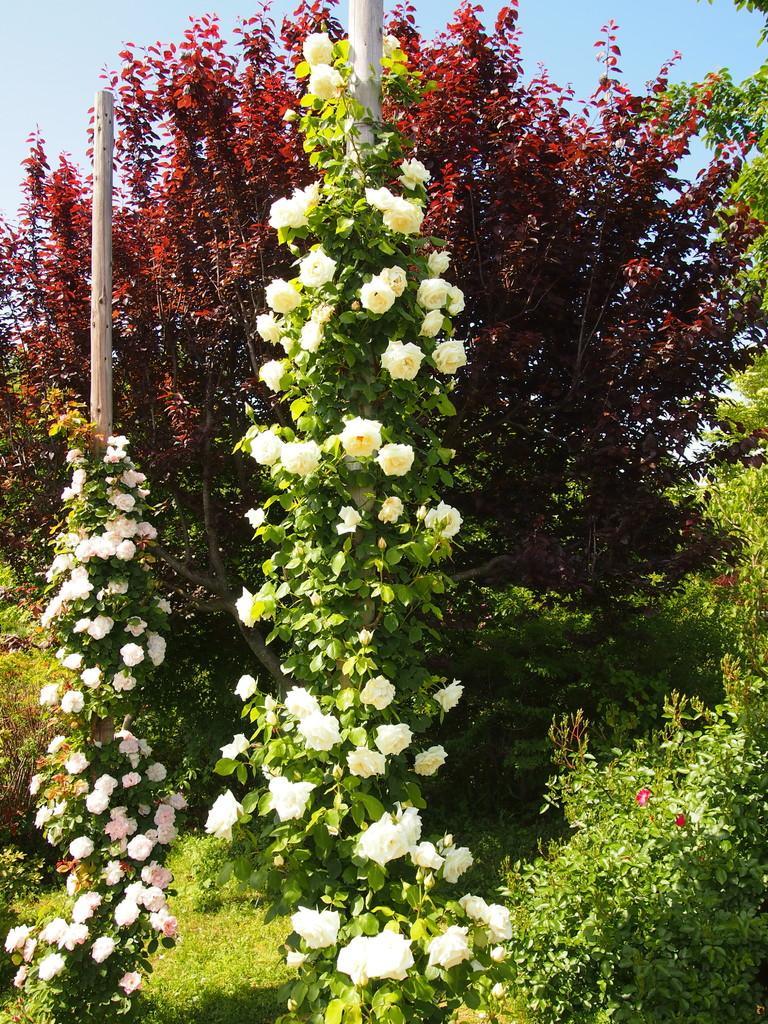Can you describe this image briefly? In this image I can see the flowers to the plants. These flowers are in pink, white, red and cream color. In the background I can see the pole, red color plant and the sky. 